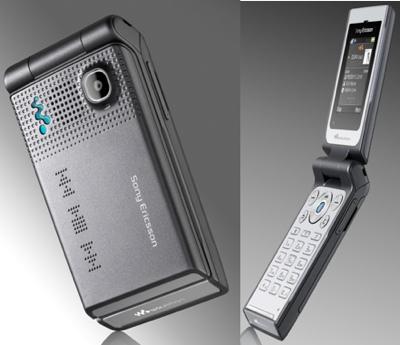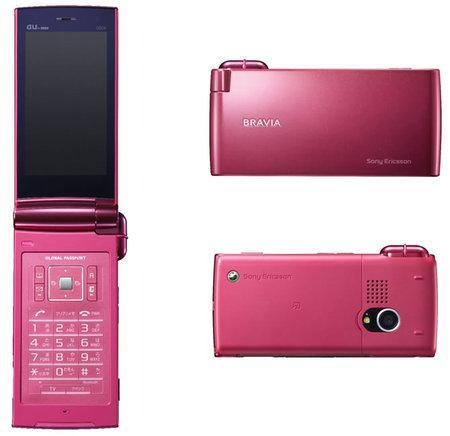The first image is the image on the left, the second image is the image on the right. Analyze the images presented: Is the assertion "Exactly one flip phone is open." valid? Answer yes or no. No. The first image is the image on the left, the second image is the image on the right. Evaluate the accuracy of this statement regarding the images: "There is an open flip phone in the image on the left.". Is it true? Answer yes or no. Yes. 